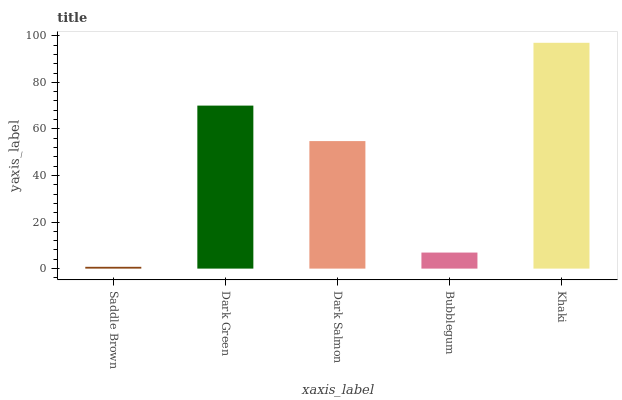Is Saddle Brown the minimum?
Answer yes or no. Yes. Is Khaki the maximum?
Answer yes or no. Yes. Is Dark Green the minimum?
Answer yes or no. No. Is Dark Green the maximum?
Answer yes or no. No. Is Dark Green greater than Saddle Brown?
Answer yes or no. Yes. Is Saddle Brown less than Dark Green?
Answer yes or no. Yes. Is Saddle Brown greater than Dark Green?
Answer yes or no. No. Is Dark Green less than Saddle Brown?
Answer yes or no. No. Is Dark Salmon the high median?
Answer yes or no. Yes. Is Dark Salmon the low median?
Answer yes or no. Yes. Is Saddle Brown the high median?
Answer yes or no. No. Is Dark Green the low median?
Answer yes or no. No. 